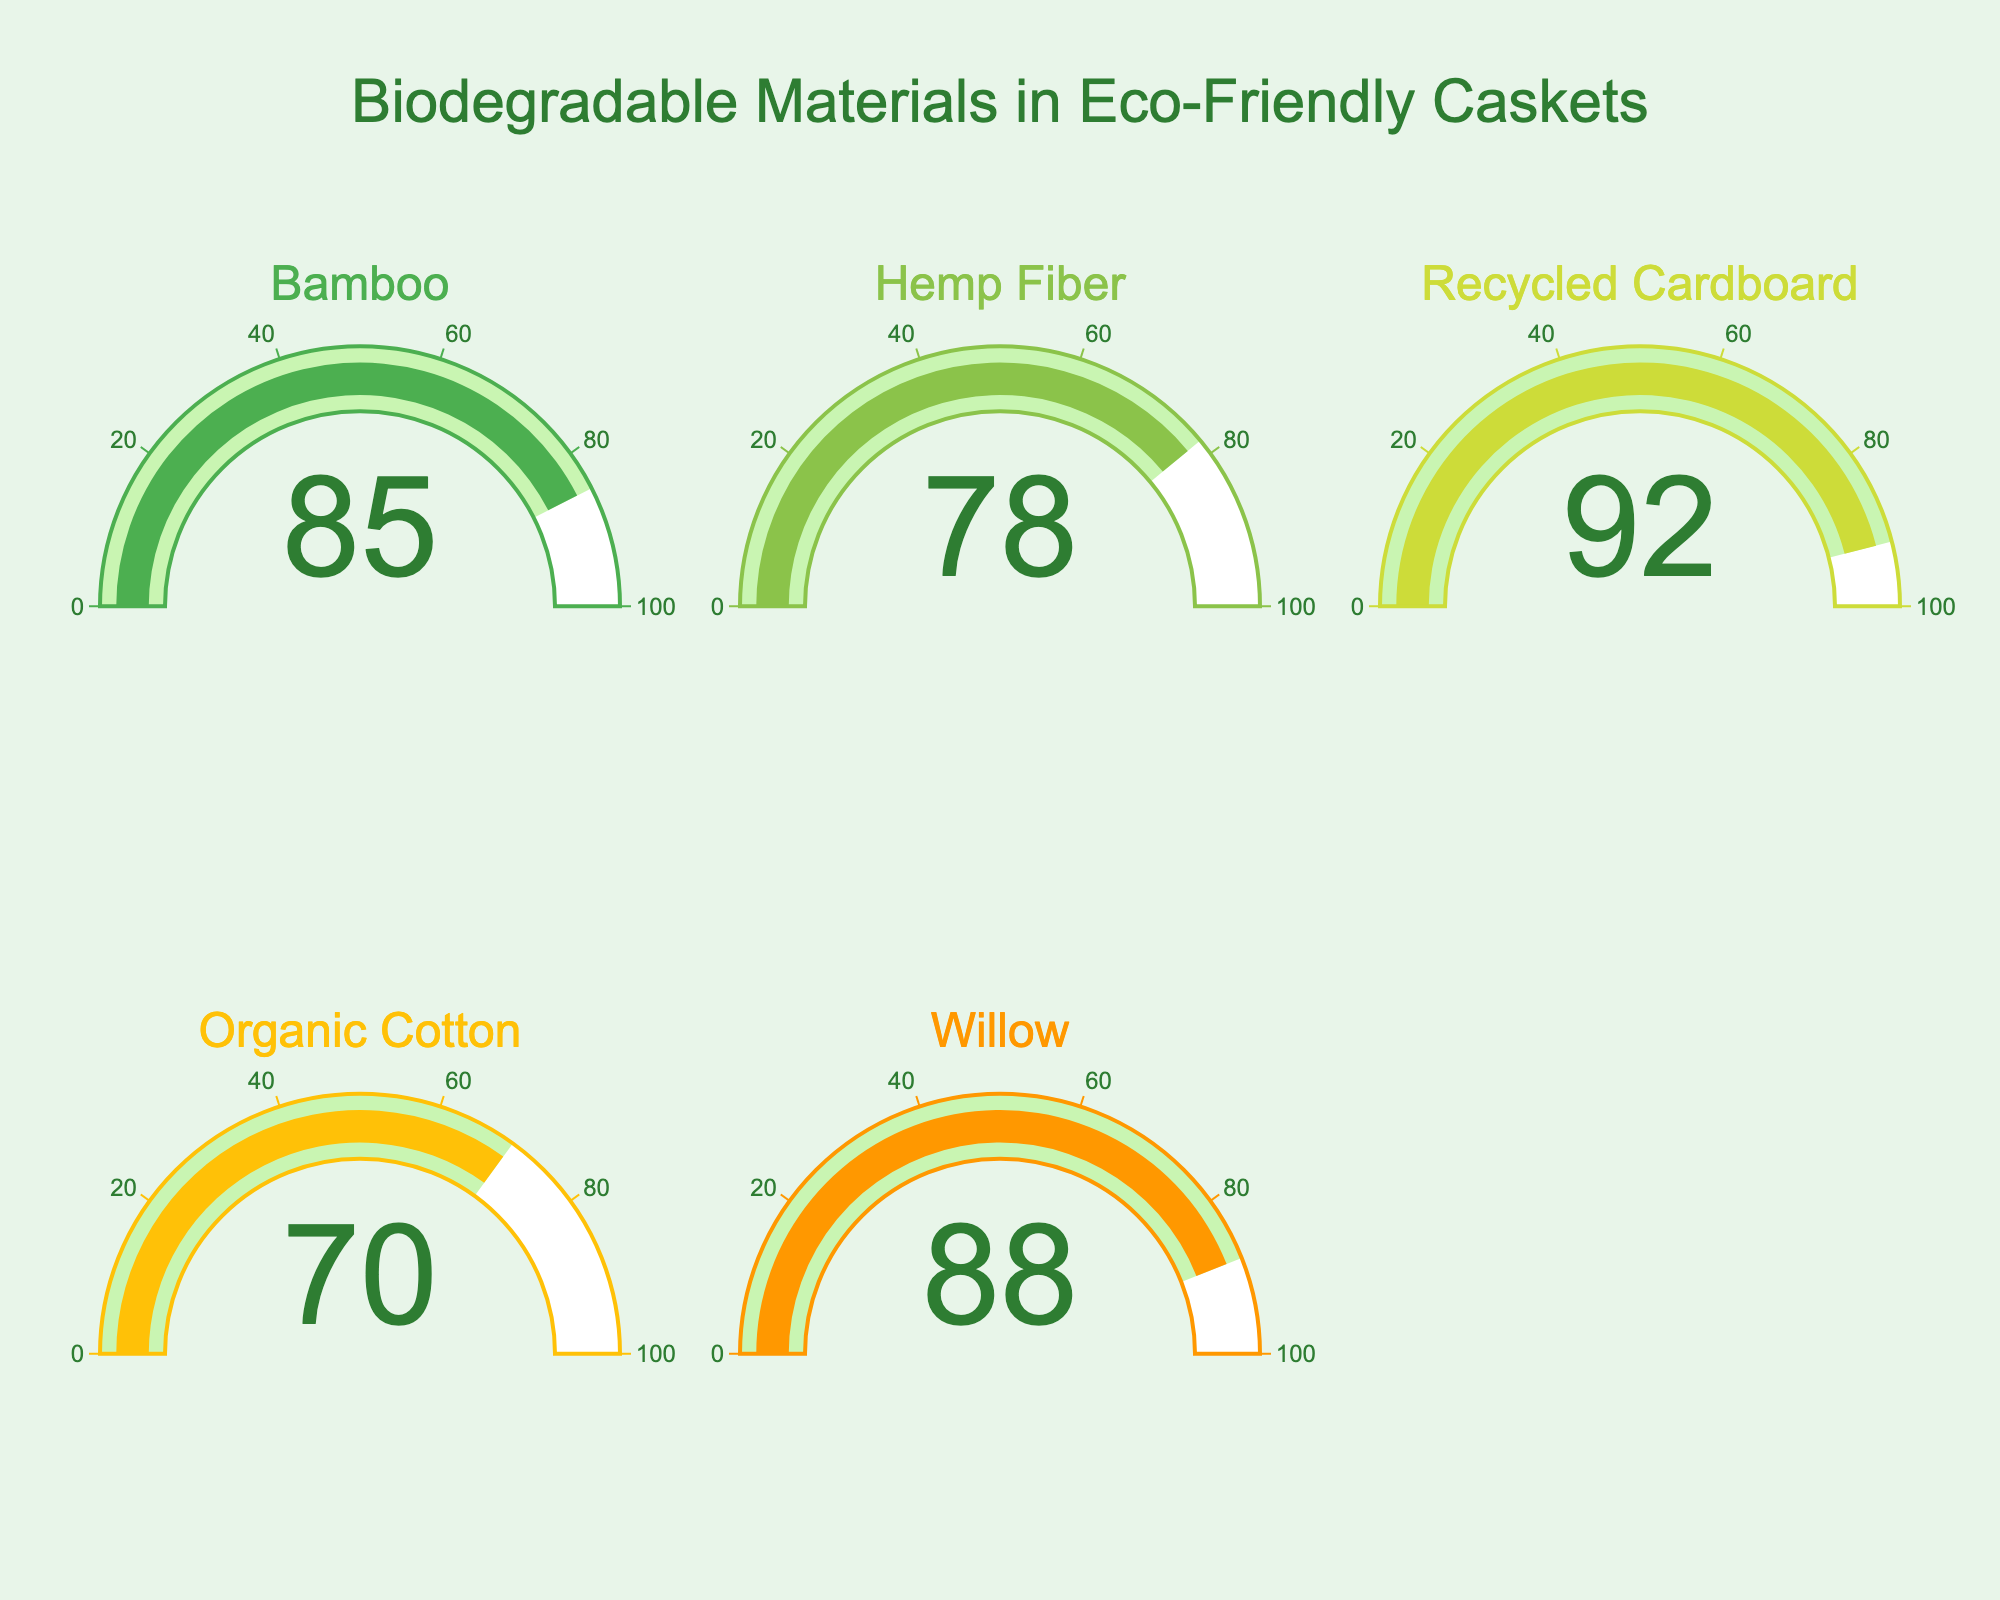What's the percentage of biodegradable material for Recycled Cardboard? The gauge chart for Recycled Cardboard shows a numeric value.
Answer: 92 Which material uses 78% biodegradable content? By looking at the gauge charts, Hemp Fiber is the material with 78% biodegradable content as indicated by the number on its gauge.
Answer: Hemp Fiber Which material has the least percentage of biodegradable content? By comparing all the values on the gauge charts, Organic Cotton has the lowest percentage at 70%.
Answer: Organic Cotton What is the average percentage of biodegradable materials used in these caskets? Sum all the percentages: 85 (Bamboo) + 78 (Hemp Fiber) + 92 (Recycled Cardboard) + 70 (Organic Cotton) + 88 (Willow) = 413. Divide by 5. 413 / 5 = 82.6
Answer: 82.6 Are there any materials with a biodegradable percentage higher than 85%? By comparing the values on the gauges, both Recycled Cardboard (92%) and Willow (88%) have biodegradable content percentages higher than 85%.
Answer: Yes Which material has the second highest percentage of biodegradable content? By arranging the percentages in descending order (92, 88, 85, 78, 70), Willow with 88% is the second highest.
Answer: Willow How much higher is the biodegradable percentage of Recycled Cardboard compared to Organic Cotton? Subtract Organic Cotton's percentage from Recycled Cardboard's: 92 - 70 = 22.
Answer: 22 Is the biodegradable content of Bamboo greater than that of Hemp Fiber and Organic Cotton combined? Sum the percentages of Hemp Fiber (78) and Organic Cotton (70): 78 + 70 = 148. Compare with Bamboo's 85%. 85 < 148.
Answer: No Which materials have higher biodegradable percentages than the average? The average is 82.6%. Recycled Cardboard (92%), Willow (88%), and Bamboo (85%) have higher percentages.
Answer: Recycled Cardboard, Willow, Bamboo 